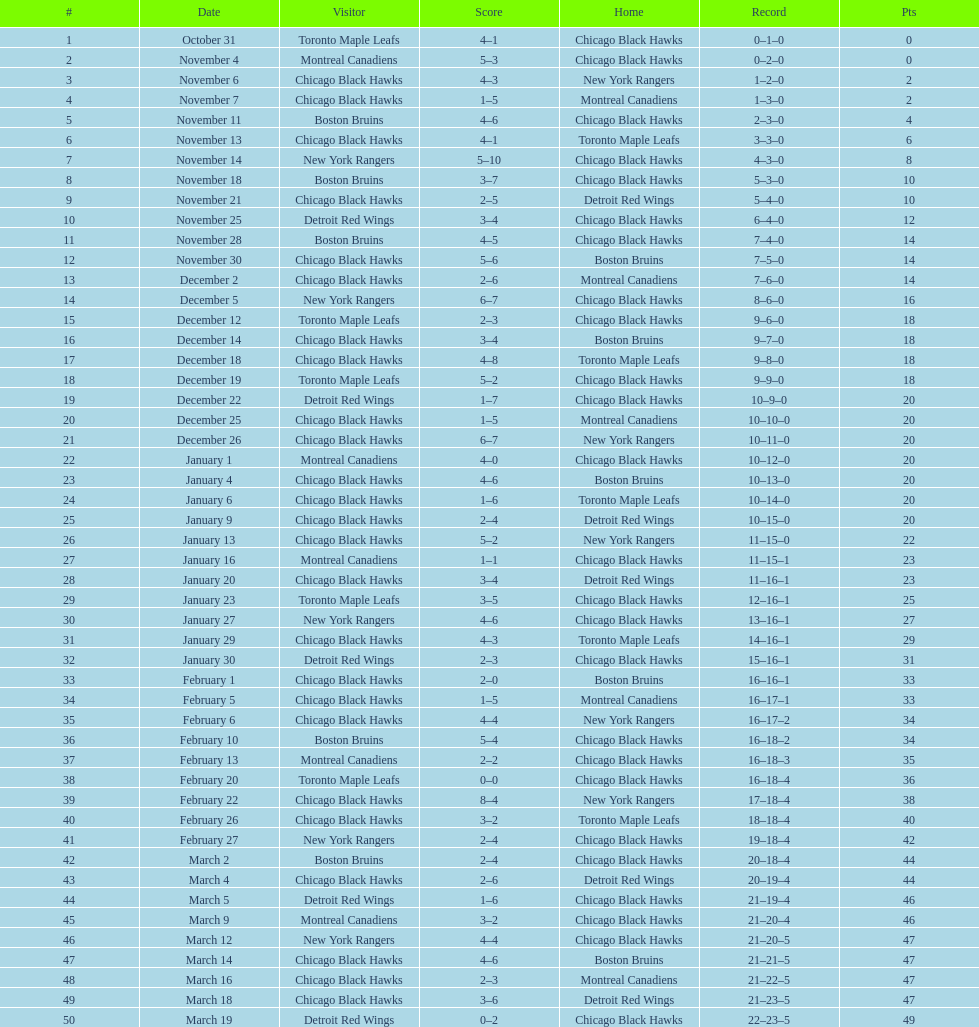What was the disparity in score during the december 19th triumph? 3. Can you give me this table as a dict? {'header': ['#', 'Date', 'Visitor', 'Score', 'Home', 'Record', 'Pts'], 'rows': [['1', 'October 31', 'Toronto Maple Leafs', '4–1', 'Chicago Black Hawks', '0–1–0', '0'], ['2', 'November 4', 'Montreal Canadiens', '5–3', 'Chicago Black Hawks', '0–2–0', '0'], ['3', 'November 6', 'Chicago Black Hawks', '4–3', 'New York Rangers', '1–2–0', '2'], ['4', 'November 7', 'Chicago Black Hawks', '1–5', 'Montreal Canadiens', '1–3–0', '2'], ['5', 'November 11', 'Boston Bruins', '4–6', 'Chicago Black Hawks', '2–3–0', '4'], ['6', 'November 13', 'Chicago Black Hawks', '4–1', 'Toronto Maple Leafs', '3–3–0', '6'], ['7', 'November 14', 'New York Rangers', '5–10', 'Chicago Black Hawks', '4–3–0', '8'], ['8', 'November 18', 'Boston Bruins', '3–7', 'Chicago Black Hawks', '5–3–0', '10'], ['9', 'November 21', 'Chicago Black Hawks', '2–5', 'Detroit Red Wings', '5–4–0', '10'], ['10', 'November 25', 'Detroit Red Wings', '3–4', 'Chicago Black Hawks', '6–4–0', '12'], ['11', 'November 28', 'Boston Bruins', '4–5', 'Chicago Black Hawks', '7–4–0', '14'], ['12', 'November 30', 'Chicago Black Hawks', '5–6', 'Boston Bruins', '7–5–0', '14'], ['13', 'December 2', 'Chicago Black Hawks', '2–6', 'Montreal Canadiens', '7–6–0', '14'], ['14', 'December 5', 'New York Rangers', '6–7', 'Chicago Black Hawks', '8–6–0', '16'], ['15', 'December 12', 'Toronto Maple Leafs', '2–3', 'Chicago Black Hawks', '9–6–0', '18'], ['16', 'December 14', 'Chicago Black Hawks', '3–4', 'Boston Bruins', '9–7–0', '18'], ['17', 'December 18', 'Chicago Black Hawks', '4–8', 'Toronto Maple Leafs', '9–8–0', '18'], ['18', 'December 19', 'Toronto Maple Leafs', '5–2', 'Chicago Black Hawks', '9–9–0', '18'], ['19', 'December 22', 'Detroit Red Wings', '1–7', 'Chicago Black Hawks', '10–9–0', '20'], ['20', 'December 25', 'Chicago Black Hawks', '1–5', 'Montreal Canadiens', '10–10–0', '20'], ['21', 'December 26', 'Chicago Black Hawks', '6–7', 'New York Rangers', '10–11–0', '20'], ['22', 'January 1', 'Montreal Canadiens', '4–0', 'Chicago Black Hawks', '10–12–0', '20'], ['23', 'January 4', 'Chicago Black Hawks', '4–6', 'Boston Bruins', '10–13–0', '20'], ['24', 'January 6', 'Chicago Black Hawks', '1–6', 'Toronto Maple Leafs', '10–14–0', '20'], ['25', 'January 9', 'Chicago Black Hawks', '2–4', 'Detroit Red Wings', '10–15–0', '20'], ['26', 'January 13', 'Chicago Black Hawks', '5–2', 'New York Rangers', '11–15–0', '22'], ['27', 'January 16', 'Montreal Canadiens', '1–1', 'Chicago Black Hawks', '11–15–1', '23'], ['28', 'January 20', 'Chicago Black Hawks', '3–4', 'Detroit Red Wings', '11–16–1', '23'], ['29', 'January 23', 'Toronto Maple Leafs', '3–5', 'Chicago Black Hawks', '12–16–1', '25'], ['30', 'January 27', 'New York Rangers', '4–6', 'Chicago Black Hawks', '13–16–1', '27'], ['31', 'January 29', 'Chicago Black Hawks', '4–3', 'Toronto Maple Leafs', '14–16–1', '29'], ['32', 'January 30', 'Detroit Red Wings', '2–3', 'Chicago Black Hawks', '15–16–1', '31'], ['33', 'February 1', 'Chicago Black Hawks', '2–0', 'Boston Bruins', '16–16–1', '33'], ['34', 'February 5', 'Chicago Black Hawks', '1–5', 'Montreal Canadiens', '16–17–1', '33'], ['35', 'February 6', 'Chicago Black Hawks', '4–4', 'New York Rangers', '16–17–2', '34'], ['36', 'February 10', 'Boston Bruins', '5–4', 'Chicago Black Hawks', '16–18–2', '34'], ['37', 'February 13', 'Montreal Canadiens', '2–2', 'Chicago Black Hawks', '16–18–3', '35'], ['38', 'February 20', 'Toronto Maple Leafs', '0–0', 'Chicago Black Hawks', '16–18–4', '36'], ['39', 'February 22', 'Chicago Black Hawks', '8–4', 'New York Rangers', '17–18–4', '38'], ['40', 'February 26', 'Chicago Black Hawks', '3–2', 'Toronto Maple Leafs', '18–18–4', '40'], ['41', 'February 27', 'New York Rangers', '2–4', 'Chicago Black Hawks', '19–18–4', '42'], ['42', 'March 2', 'Boston Bruins', '2–4', 'Chicago Black Hawks', '20–18–4', '44'], ['43', 'March 4', 'Chicago Black Hawks', '2–6', 'Detroit Red Wings', '20–19–4', '44'], ['44', 'March 5', 'Detroit Red Wings', '1–6', 'Chicago Black Hawks', '21–19–4', '46'], ['45', 'March 9', 'Montreal Canadiens', '3–2', 'Chicago Black Hawks', '21–20–4', '46'], ['46', 'March 12', 'New York Rangers', '4–4', 'Chicago Black Hawks', '21–20–5', '47'], ['47', 'March 14', 'Chicago Black Hawks', '4–6', 'Boston Bruins', '21–21–5', '47'], ['48', 'March 16', 'Chicago Black Hawks', '2–3', 'Montreal Canadiens', '21–22–5', '47'], ['49', 'March 18', 'Chicago Black Hawks', '3–6', 'Detroit Red Wings', '21–23–5', '47'], ['50', 'March 19', 'Detroit Red Wings', '0–2', 'Chicago Black Hawks', '22–23–5', '49']]} 